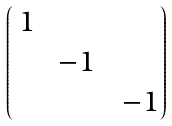<formula> <loc_0><loc_0><loc_500><loc_500>\begin{pmatrix} \, 1 & & \\ & \, - 1 \, & \\ & & \, - 1 \end{pmatrix}</formula> 